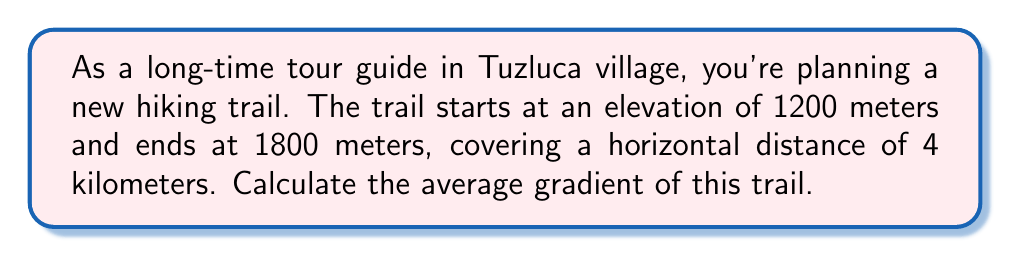What is the answer to this math problem? To solve this problem, we'll use the concept of gradient in field theory. The gradient represents the rate of change of elevation with respect to horizontal distance.

Step 1: Define the variables
Let $\Delta h$ be the change in elevation (vertical distance)
Let $\Delta x$ be the horizontal distance

Step 2: Calculate $\Delta h$
$\Delta h = \text{Final elevation} - \text{Initial elevation}$
$\Delta h = 1800 \text{ m} - 1200 \text{ m} = 600 \text{ m}$

Step 3: Identify $\Delta x$
$\Delta x = 4 \text{ km} = 4000 \text{ m}$

Step 4: Calculate the gradient
The gradient is given by the formula:

$$\text{Gradient} = \frac{\Delta h}{\Delta x}$$

Substituting our values:

$$\text{Gradient} = \frac{600 \text{ m}}{4000 \text{ m}} = 0.15$$

Step 5: Convert to percentage (optional)
To express as a percentage, multiply by 100:

$$\text{Gradient} = 0.15 \times 100\% = 15\%$$

This means the trail rises 15 meters for every 100 meters of horizontal distance.
Answer: $0.15$ or $15\%$ 